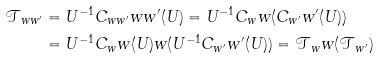Convert formula to latex. <formula><loc_0><loc_0><loc_500><loc_500>\mathcal { T } _ { w w ^ { \prime } } & = U ^ { - 1 } C _ { w w ^ { \prime } } w w ^ { \prime } ( U ) = U ^ { - 1 } C _ { w } w ( C _ { w ^ { \prime } } w ^ { \prime } ( U ) ) \\ & = U ^ { - 1 } C _ { w } w ( U ) w ( U ^ { - 1 } C _ { w ^ { \prime } } w ^ { \prime } ( U ) ) = \mathcal { T } _ { w } w ( \mathcal { T } _ { w ^ { \prime } } )</formula> 